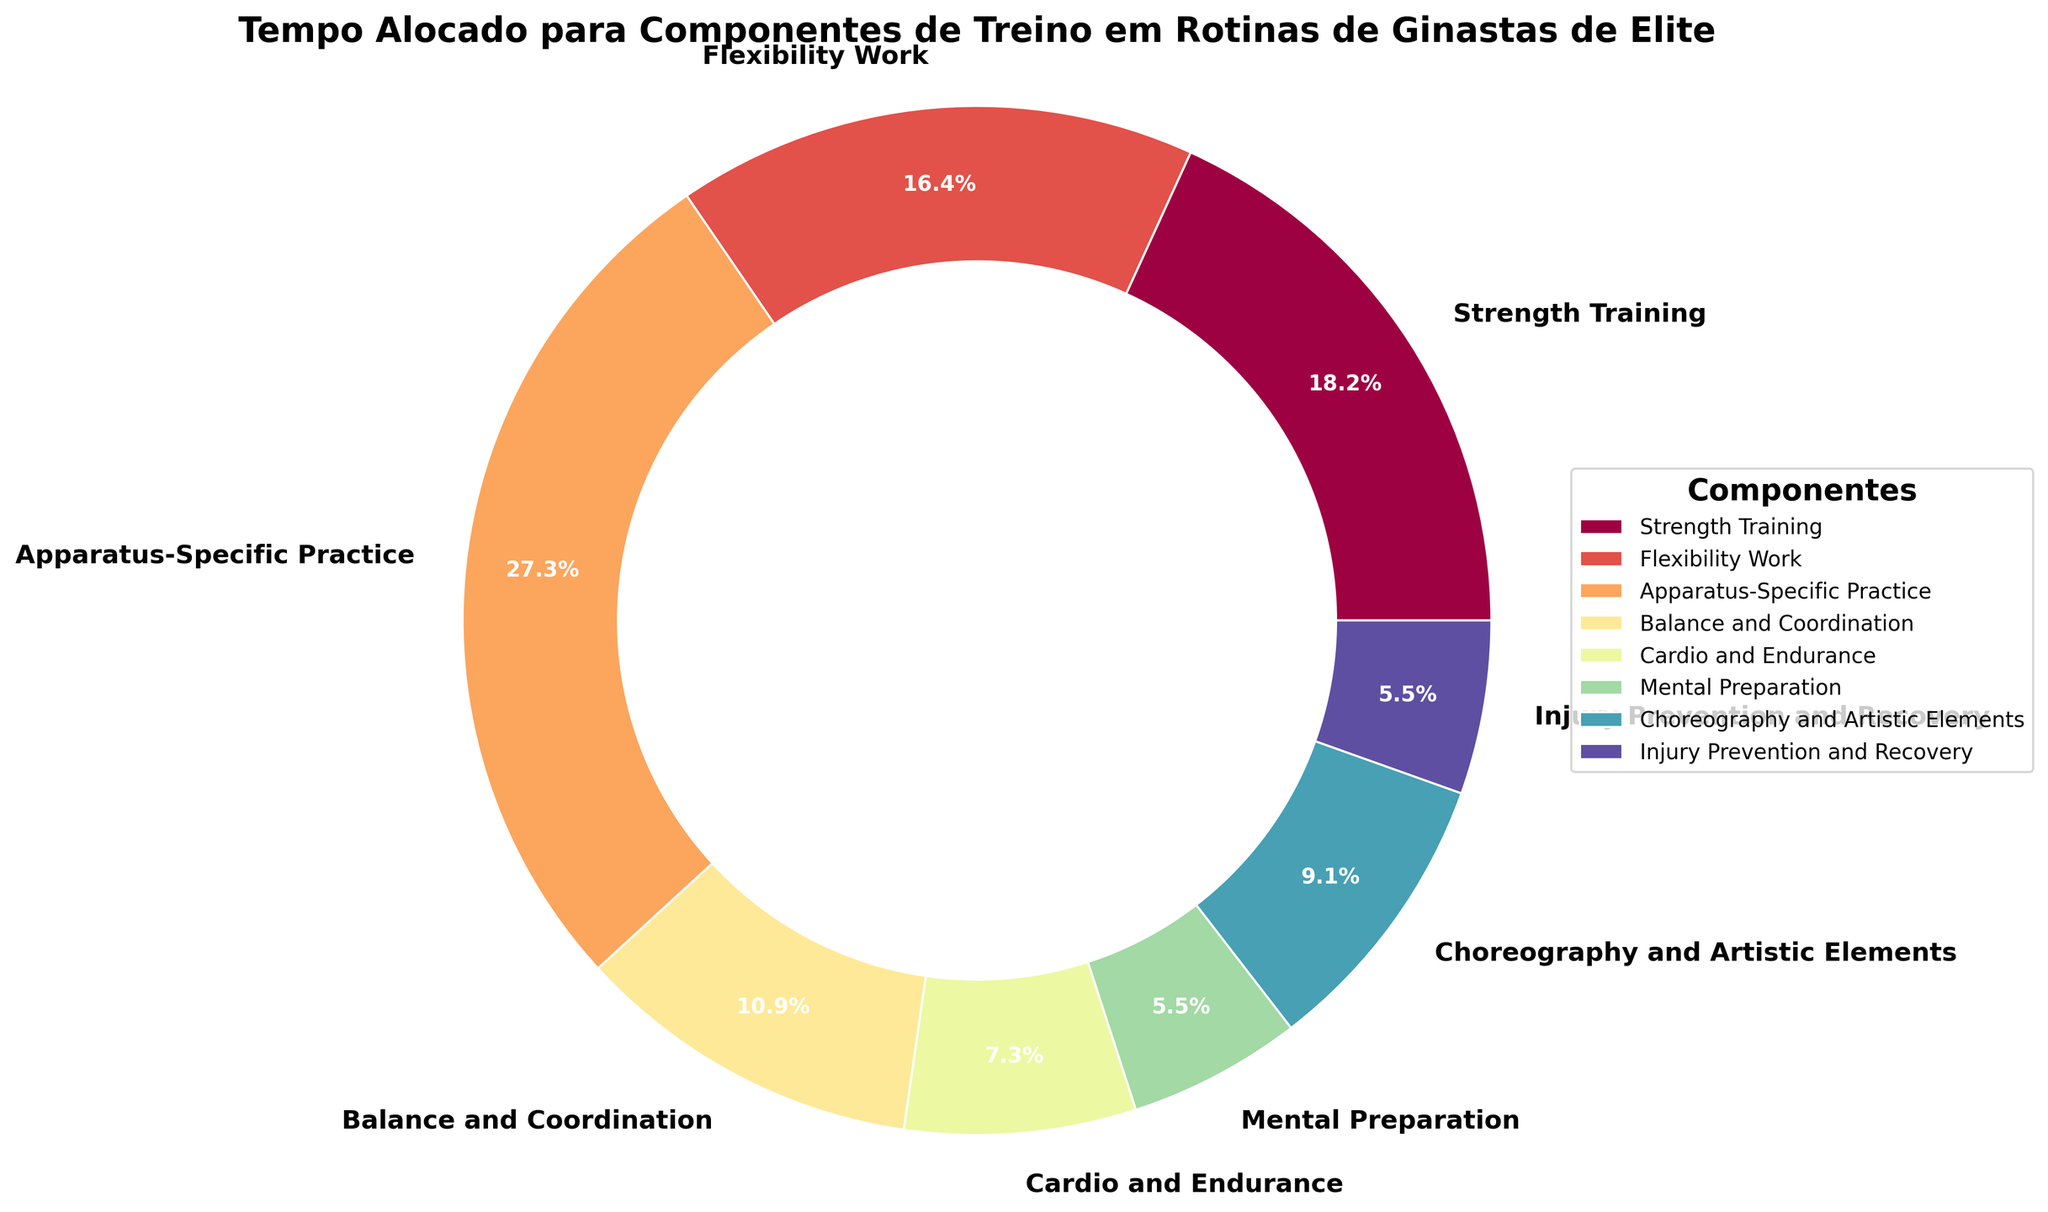Which training component has the highest time allocation? By observing the pie chart's labels and percentages, the component with the highest percentage indicates the highest allocation. Apparatus-Specific Practice has the highest with 30%.
Answer: Apparatus-Specific Practice Which training components have the same percentage of time allocation? By checking the percentages, Mental Preparation and Injury Prevention and Recovery both have 6%.
Answer: Mental Preparation, Injury Prevention and Recovery What's the total percentage of time spent on Strength Training and Flexibility Work combined? By adding the percentages of Strength Training (20%) and Flexibility Work (18%), 20 + 18 = 38%.
Answer: 38% Which component receives less time, Balance and Coordination or Cardio and Endurance? Balance and Coordination has 12%, while Cardio and Endurance has 8%, so Cardio and Endurance receives less time.
Answer: Cardio and Endurance What is the difference in time allocation between Choreography and Artistic Elements and Mental Preparation? Choreography and Artistic Elements have 10%, while Mental Preparation has 6%. The difference is 10 - 6 = 4%.
Answer: 4% How does the time allocation of Strength Training compare to Flexibility Work? Strength Training is allocated 20% and Flexibility Work is allocated 18%. Strength Training has a higher allocation.
Answer: Strength Training What’s the combined percentage of time spent on Balance and Coordination and Mental Preparation? Balance and Coordination has 12% and Mental Preparation has 6%, so combined it’s 12 + 6 = 18%.
Answer: 18% Which training component takes up more than a quarter of the total time? A quarter of the total time is 25%. Apparatus-Specific Practice is the only component with more than 25%, at 30%.
Answer: Apparatus-Specific Practice 